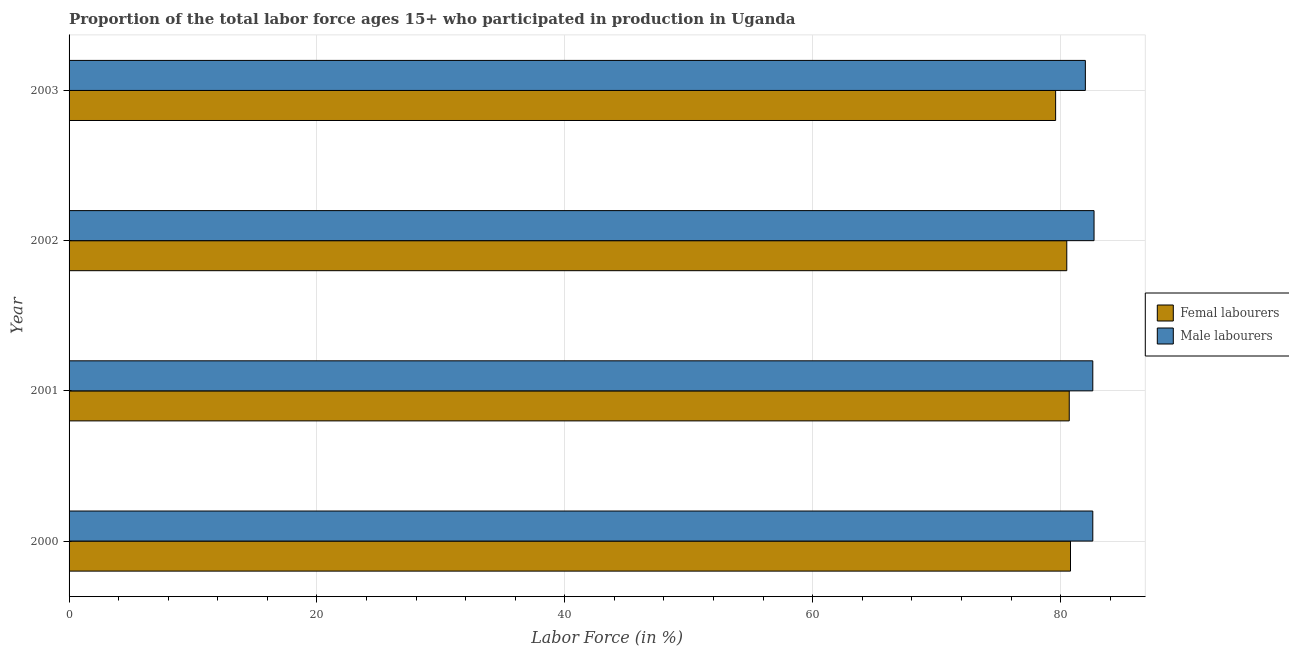How many different coloured bars are there?
Give a very brief answer. 2. How many groups of bars are there?
Keep it short and to the point. 4. Are the number of bars on each tick of the Y-axis equal?
Keep it short and to the point. Yes. How many bars are there on the 2nd tick from the bottom?
Your answer should be compact. 2. What is the percentage of female labor force in 2002?
Offer a terse response. 80.5. Across all years, what is the maximum percentage of male labour force?
Make the answer very short. 82.7. In which year was the percentage of female labor force minimum?
Provide a succinct answer. 2003. What is the total percentage of female labor force in the graph?
Your answer should be compact. 321.6. What is the difference between the percentage of male labour force in 2000 and the percentage of female labor force in 2003?
Offer a very short reply. 3. What is the average percentage of male labour force per year?
Ensure brevity in your answer.  82.47. Is the percentage of male labour force in 2000 less than that in 2002?
Offer a very short reply. Yes. In how many years, is the percentage of female labor force greater than the average percentage of female labor force taken over all years?
Your response must be concise. 3. Is the sum of the percentage of female labor force in 2001 and 2002 greater than the maximum percentage of male labour force across all years?
Offer a very short reply. Yes. What does the 1st bar from the top in 2000 represents?
Offer a very short reply. Male labourers. What does the 1st bar from the bottom in 2000 represents?
Offer a very short reply. Femal labourers. Does the graph contain any zero values?
Make the answer very short. No. Where does the legend appear in the graph?
Offer a terse response. Center right. How many legend labels are there?
Provide a succinct answer. 2. What is the title of the graph?
Provide a succinct answer. Proportion of the total labor force ages 15+ who participated in production in Uganda. Does "Infant" appear as one of the legend labels in the graph?
Ensure brevity in your answer.  No. What is the Labor Force (in %) in Femal labourers in 2000?
Offer a very short reply. 80.8. What is the Labor Force (in %) in Male labourers in 2000?
Provide a succinct answer. 82.6. What is the Labor Force (in %) of Femal labourers in 2001?
Give a very brief answer. 80.7. What is the Labor Force (in %) of Male labourers in 2001?
Give a very brief answer. 82.6. What is the Labor Force (in %) in Femal labourers in 2002?
Ensure brevity in your answer.  80.5. What is the Labor Force (in %) in Male labourers in 2002?
Your response must be concise. 82.7. What is the Labor Force (in %) in Femal labourers in 2003?
Make the answer very short. 79.6. Across all years, what is the maximum Labor Force (in %) of Femal labourers?
Provide a short and direct response. 80.8. Across all years, what is the maximum Labor Force (in %) in Male labourers?
Offer a terse response. 82.7. Across all years, what is the minimum Labor Force (in %) of Femal labourers?
Provide a short and direct response. 79.6. Across all years, what is the minimum Labor Force (in %) of Male labourers?
Provide a succinct answer. 82. What is the total Labor Force (in %) in Femal labourers in the graph?
Offer a very short reply. 321.6. What is the total Labor Force (in %) of Male labourers in the graph?
Provide a succinct answer. 329.9. What is the difference between the Labor Force (in %) of Male labourers in 2000 and that in 2001?
Offer a terse response. 0. What is the difference between the Labor Force (in %) of Femal labourers in 2000 and that in 2002?
Your response must be concise. 0.3. What is the difference between the Labor Force (in %) of Male labourers in 2000 and that in 2002?
Provide a succinct answer. -0.1. What is the difference between the Labor Force (in %) in Femal labourers in 2001 and that in 2003?
Your response must be concise. 1.1. What is the difference between the Labor Force (in %) of Male labourers in 2001 and that in 2003?
Keep it short and to the point. 0.6. What is the difference between the Labor Force (in %) of Femal labourers in 2002 and that in 2003?
Provide a succinct answer. 0.9. What is the difference between the Labor Force (in %) of Male labourers in 2002 and that in 2003?
Your answer should be very brief. 0.7. What is the difference between the Labor Force (in %) in Femal labourers in 2000 and the Labor Force (in %) in Male labourers in 2003?
Keep it short and to the point. -1.2. What is the difference between the Labor Force (in %) of Femal labourers in 2001 and the Labor Force (in %) of Male labourers in 2002?
Make the answer very short. -2. What is the difference between the Labor Force (in %) in Femal labourers in 2001 and the Labor Force (in %) in Male labourers in 2003?
Give a very brief answer. -1.3. What is the average Labor Force (in %) of Femal labourers per year?
Provide a succinct answer. 80.4. What is the average Labor Force (in %) in Male labourers per year?
Give a very brief answer. 82.47. In the year 2002, what is the difference between the Labor Force (in %) of Femal labourers and Labor Force (in %) of Male labourers?
Give a very brief answer. -2.2. In the year 2003, what is the difference between the Labor Force (in %) in Femal labourers and Labor Force (in %) in Male labourers?
Your response must be concise. -2.4. What is the ratio of the Labor Force (in %) in Femal labourers in 2000 to that in 2001?
Give a very brief answer. 1. What is the ratio of the Labor Force (in %) of Male labourers in 2000 to that in 2001?
Provide a short and direct response. 1. What is the ratio of the Labor Force (in %) of Femal labourers in 2000 to that in 2003?
Offer a very short reply. 1.02. What is the ratio of the Labor Force (in %) of Male labourers in 2000 to that in 2003?
Provide a succinct answer. 1.01. What is the ratio of the Labor Force (in %) in Femal labourers in 2001 to that in 2002?
Ensure brevity in your answer.  1. What is the ratio of the Labor Force (in %) in Male labourers in 2001 to that in 2002?
Your response must be concise. 1. What is the ratio of the Labor Force (in %) of Femal labourers in 2001 to that in 2003?
Offer a very short reply. 1.01. What is the ratio of the Labor Force (in %) in Male labourers in 2001 to that in 2003?
Your response must be concise. 1.01. What is the ratio of the Labor Force (in %) in Femal labourers in 2002 to that in 2003?
Provide a succinct answer. 1.01. What is the ratio of the Labor Force (in %) in Male labourers in 2002 to that in 2003?
Provide a succinct answer. 1.01. What is the difference between the highest and the lowest Labor Force (in %) of Male labourers?
Offer a very short reply. 0.7. 